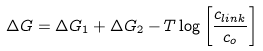Convert formula to latex. <formula><loc_0><loc_0><loc_500><loc_500>\Delta G = \Delta G _ { 1 } + \Delta G _ { 2 } - T \log \left [ \frac { c _ { l i n k } } { c _ { o } } \right ]</formula> 